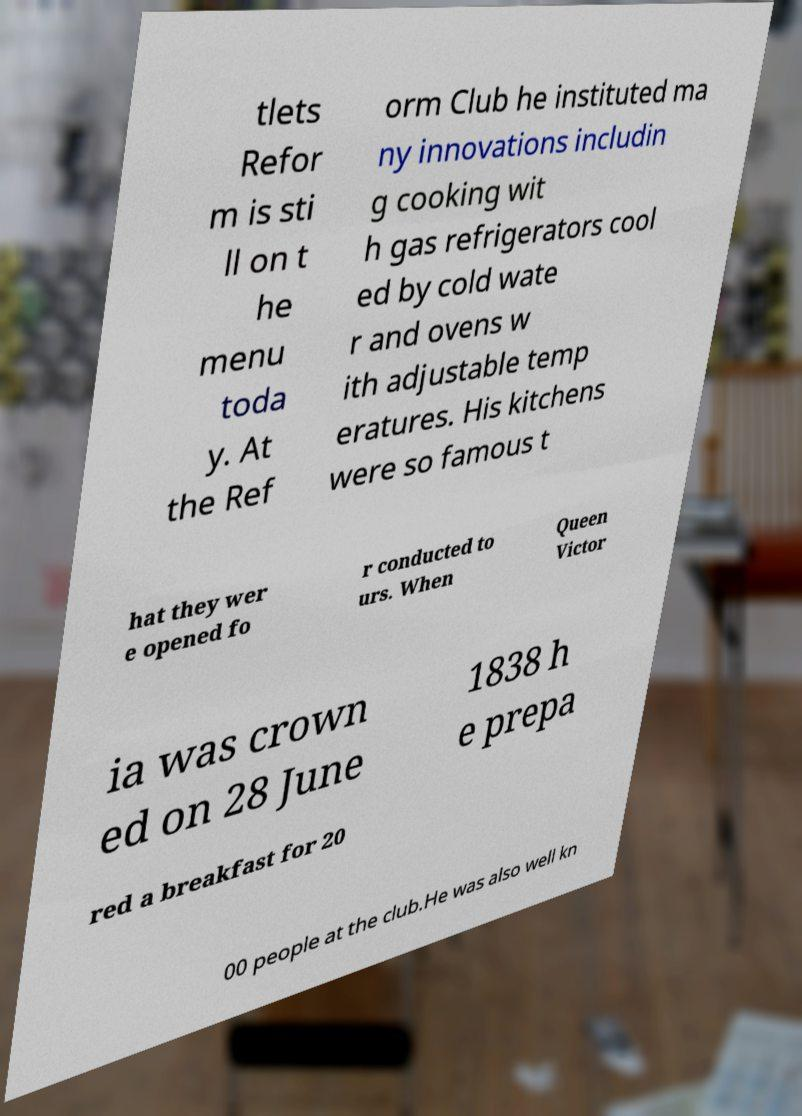Please identify and transcribe the text found in this image. tlets Refor m is sti ll on t he menu toda y. At the Ref orm Club he instituted ma ny innovations includin g cooking wit h gas refrigerators cool ed by cold wate r and ovens w ith adjustable temp eratures. His kitchens were so famous t hat they wer e opened fo r conducted to urs. When Queen Victor ia was crown ed on 28 June 1838 h e prepa red a breakfast for 20 00 people at the club.He was also well kn 